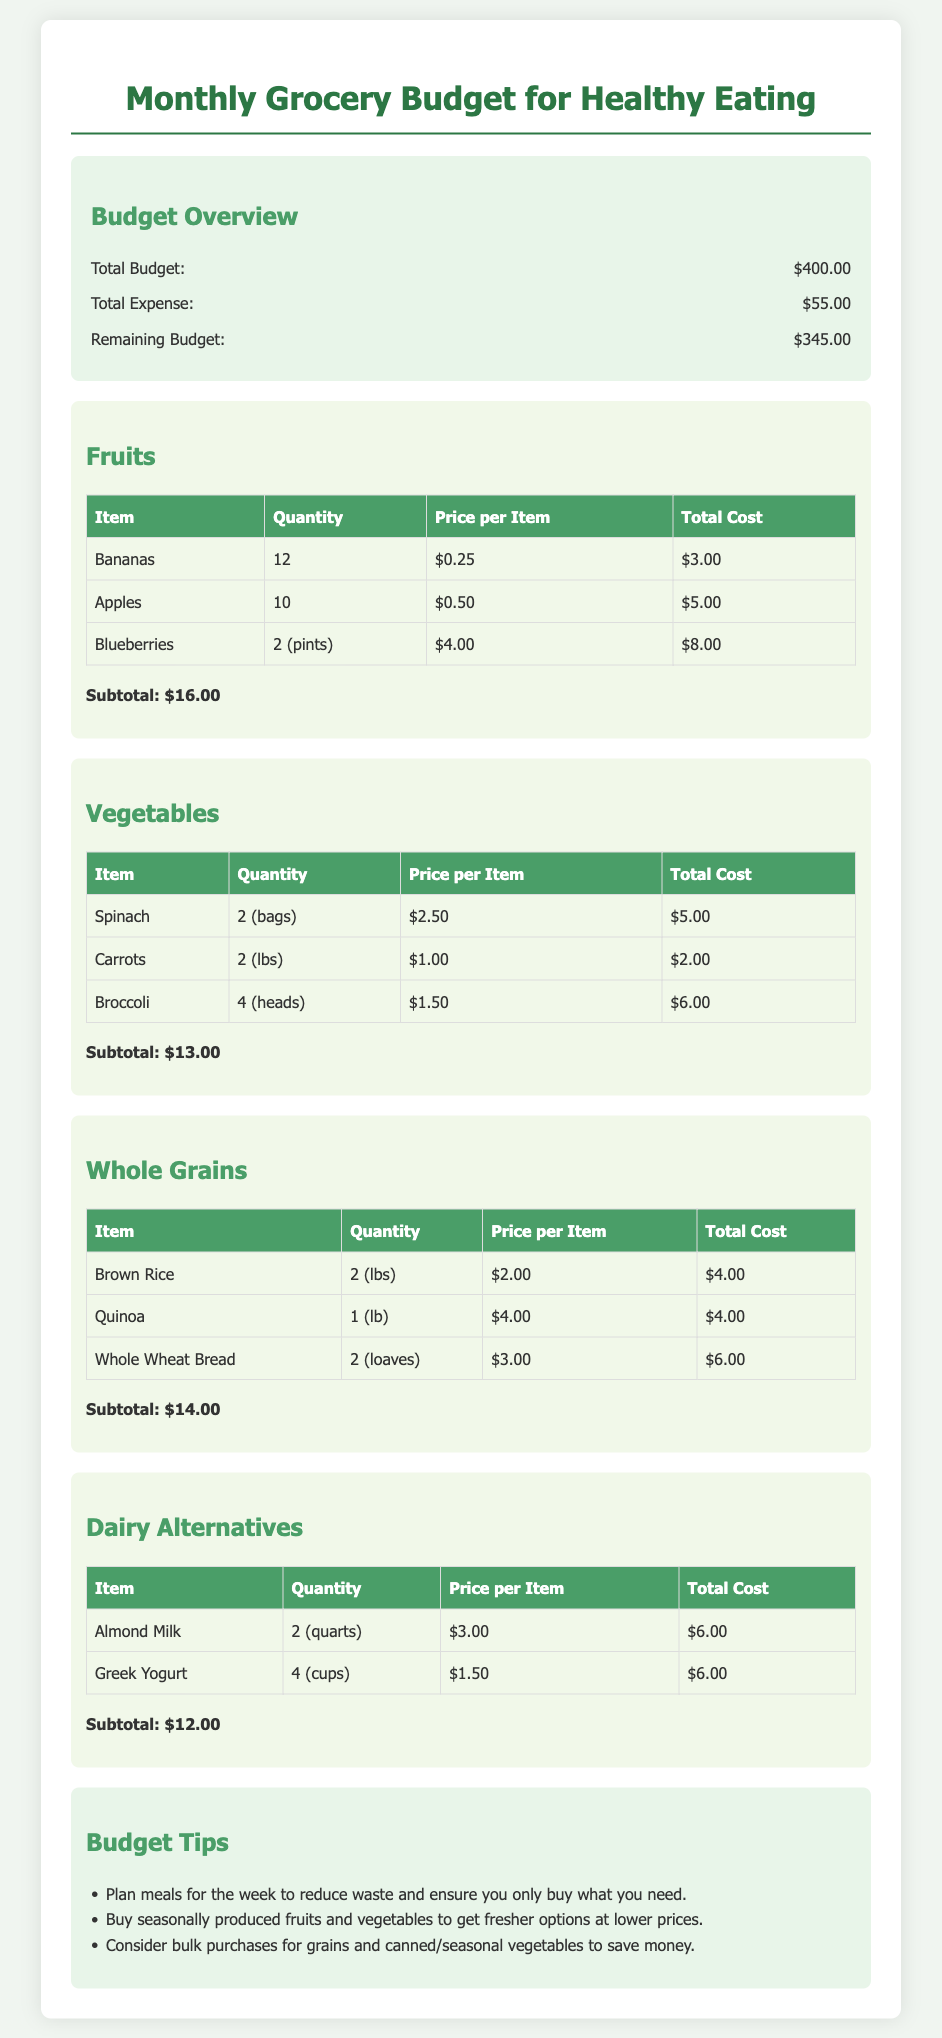What is the total budget? The total budget is stated in the budget overview section of the document, which is $400.00.
Answer: $400.00 How much has been spent so far? The total expense is also provided in the budget overview section, which is $55.00.
Answer: $55.00 What is the remaining budget? The remaining budget is calculated as total budget minus total expense, which is $400.00 - $55.00 = $345.00.
Answer: $345.00 How many bananas are included in the grocery list? The document lists the quantity of bananas in the fruits section as 12.
Answer: 12 What is the subtotal for vegetables? The subtotal for vegetables is specified at the end of the vegetables section, which is $13.00.
Answer: $13.00 Which whole grain item has the highest price per item? A comparison of the price per item for whole grains shows that Quinoa has the highest price at $4.00.
Answer: Quinoa What item has the lowest total cost in the fruits category? By evaluating the total cost of each item in the fruits section, Bananas have the lowest total cost at $3.00.
Answer: Bananas What is one tip for budgeting provided in the document? The tips section provides advice, and one example is to plan meals for the week to reduce waste.
Answer: Plan meals for the week How many quarts of almond milk are included? The document states that 2 quarts of almond milk are included in the dairy alternatives section.
Answer: 2 (quarts) 